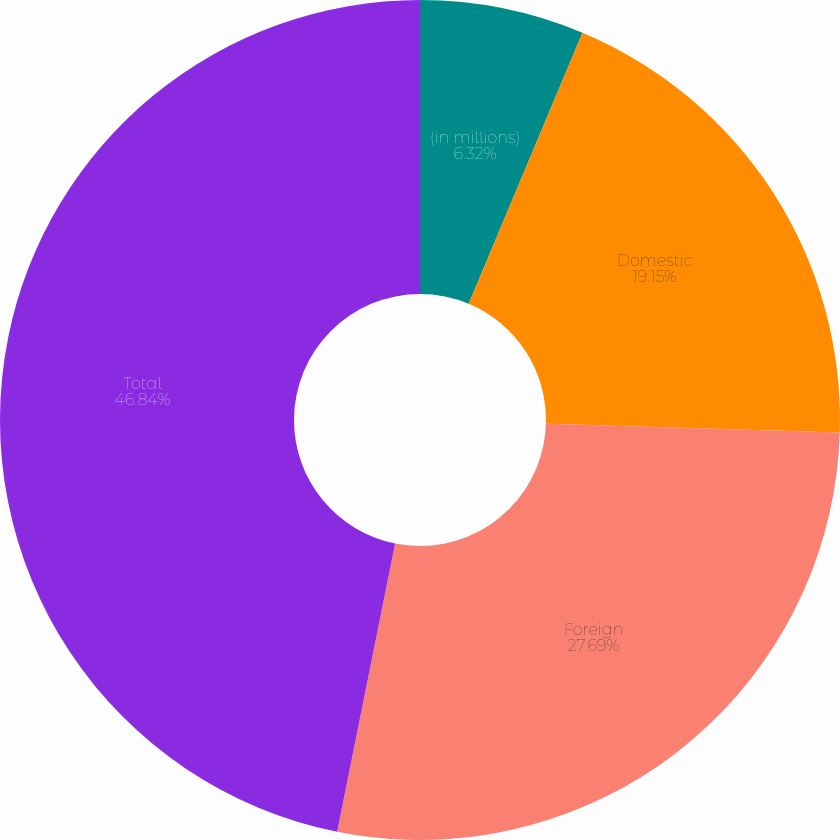Convert chart to OTSL. <chart><loc_0><loc_0><loc_500><loc_500><pie_chart><fcel>(in millions)<fcel>Domestic<fcel>Foreign<fcel>Total<nl><fcel>6.32%<fcel>19.15%<fcel>27.69%<fcel>46.84%<nl></chart> 